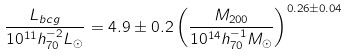<formula> <loc_0><loc_0><loc_500><loc_500>\frac { L _ { b c g } } { 1 0 ^ { 1 1 } h _ { 7 0 } ^ { - 2 } L _ { \odot } } = 4 . 9 \pm 0 . 2 \left ( \frac { M _ { 2 0 0 } } { 1 0 ^ { 1 4 } h _ { 7 0 } ^ { - 1 } M _ { \odot } } \right ) ^ { 0 . 2 6 \pm 0 . 0 4 }</formula> 